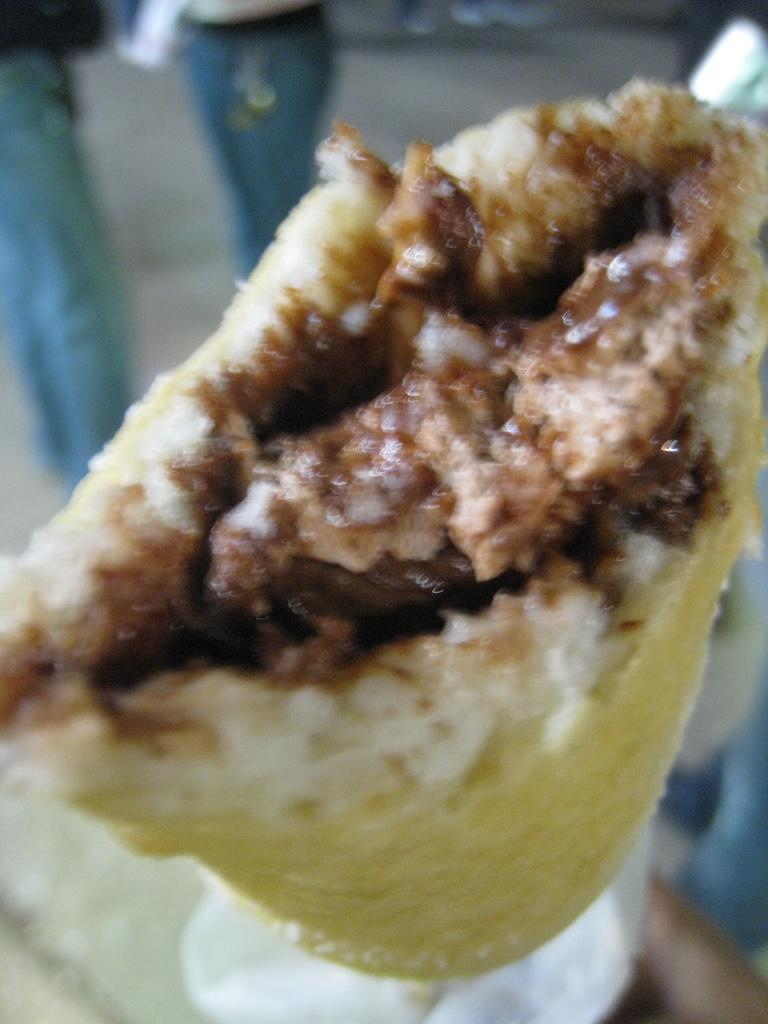What is the main subject of the image? The main subject of the image is food. Can you describe the background of the image? The background of the image is blurred. What might be present in the top left corner of the image? There are objects in the top left corner of the image that resemble legs of people. What type of stove can be seen in the image? There is no stove present in the image. How does the love between the two people in the image manifest itself? There are no people or any indication of love in the image; it primarily features food. 